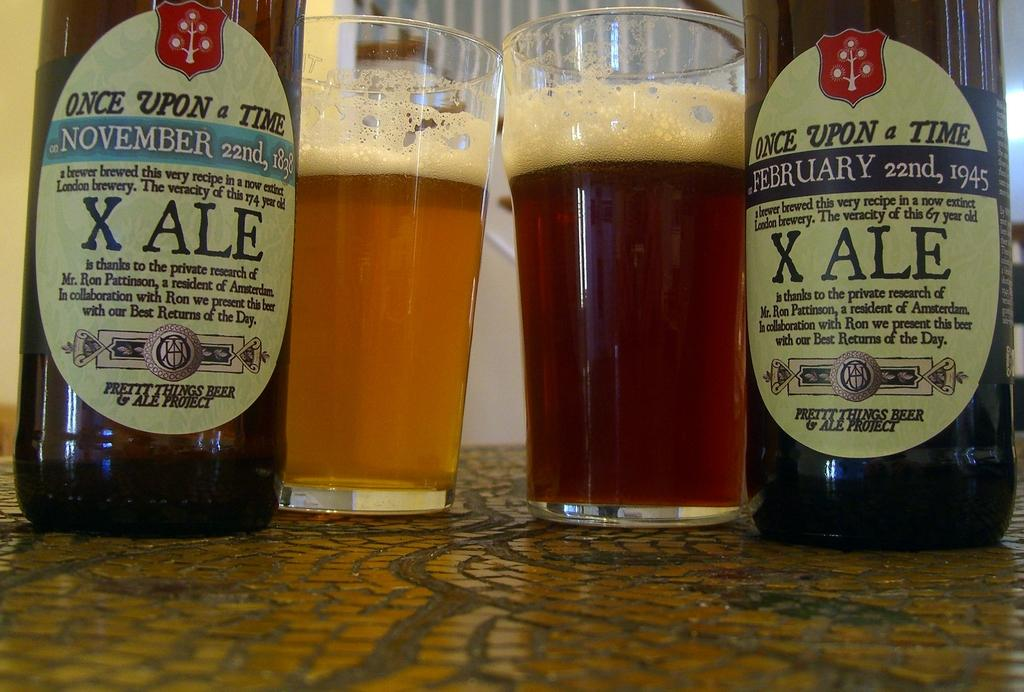<image>
Write a terse but informative summary of the picture. Two differently dated bottles of Once Upon a Time ale. 